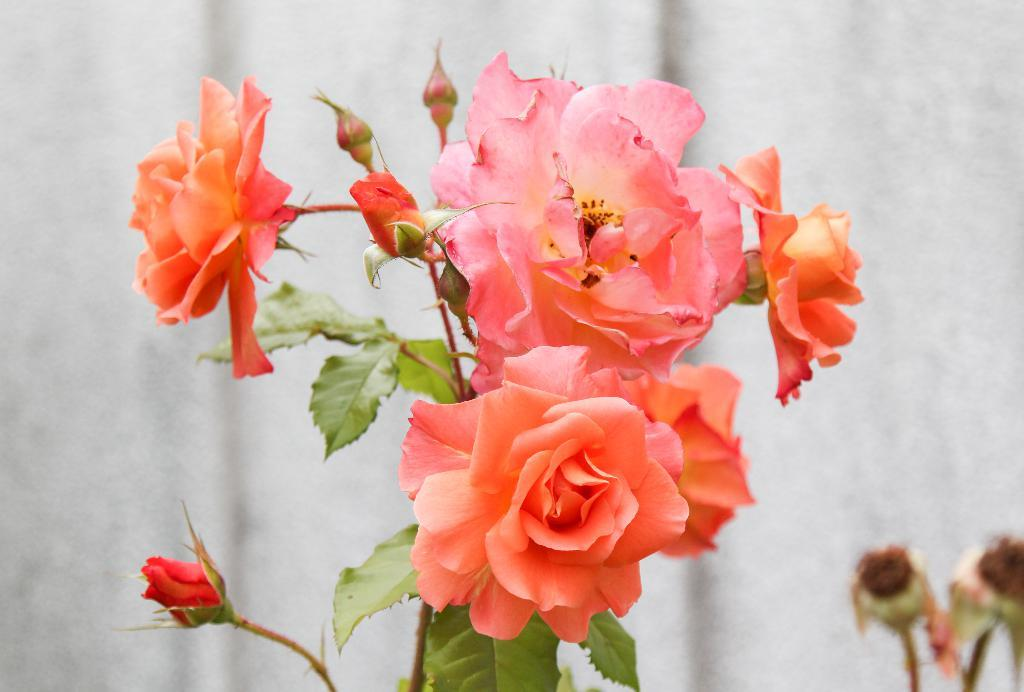What type of plant is in the image? There is a plant in the image, and it has flowers and buds. What can be seen in the background of the image? There is a background visible in the image. What is the current state of the plant's flowers? The plant has flowers, which suggests they have bloomed. What is located in the bottom right corner of the image? There are objects in the bottom right corner of the image. How many chairs are visible in the image? There are no chairs present in the image. What type of lead is used to create the plant's structure in the image? The plant is a living organism and not made of lead; it is composed of organic materials. 